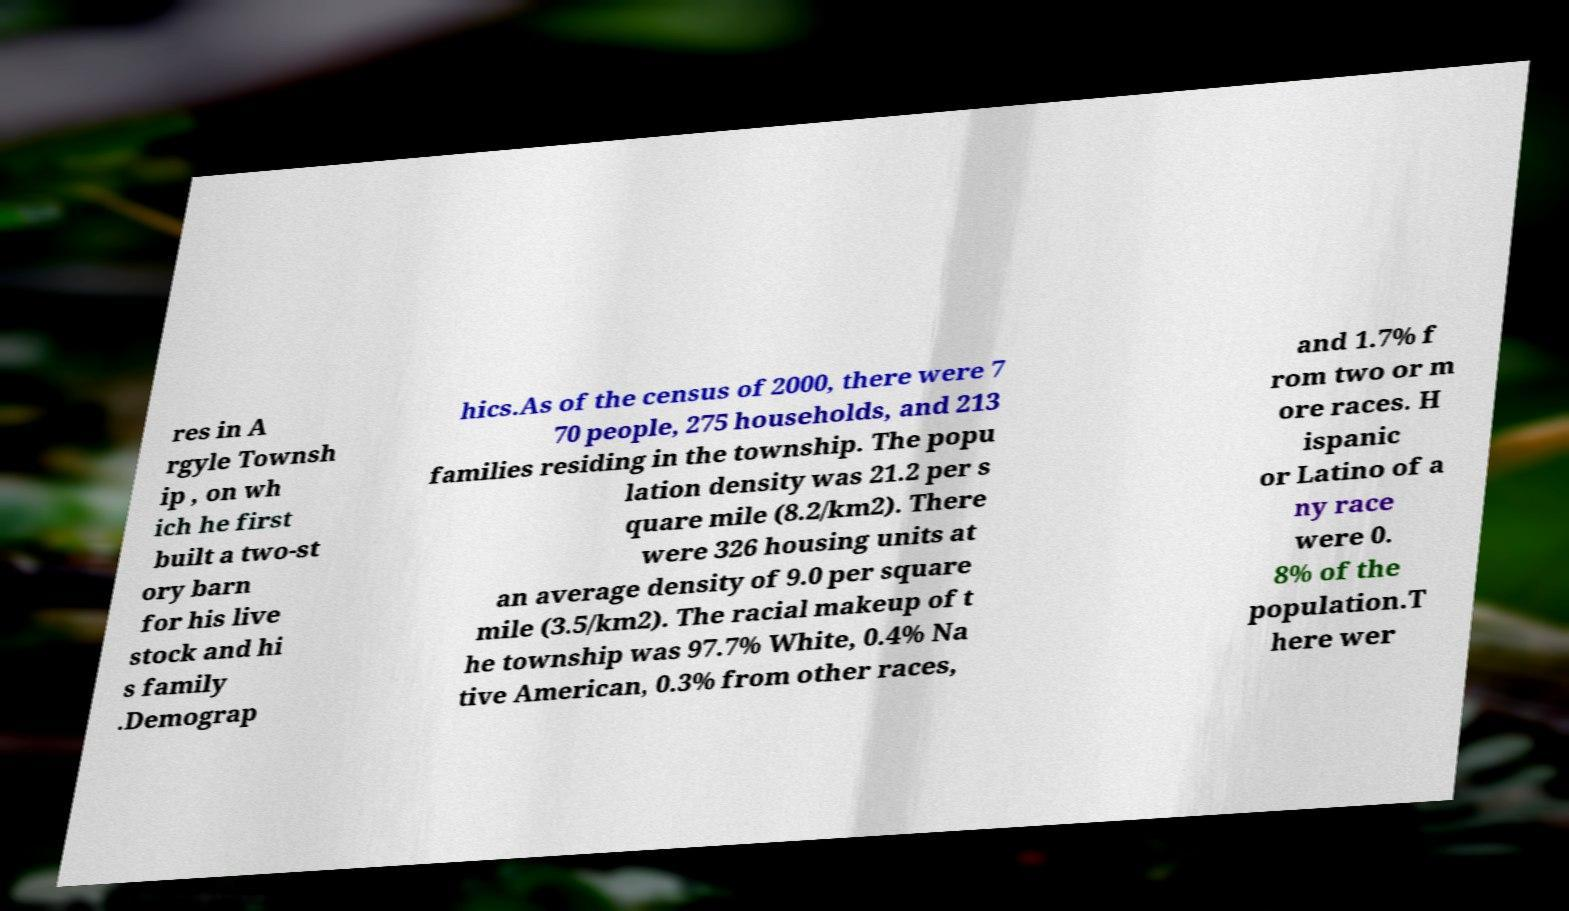Could you extract and type out the text from this image? res in A rgyle Townsh ip , on wh ich he first built a two-st ory barn for his live stock and hi s family .Demograp hics.As of the census of 2000, there were 7 70 people, 275 households, and 213 families residing in the township. The popu lation density was 21.2 per s quare mile (8.2/km2). There were 326 housing units at an average density of 9.0 per square mile (3.5/km2). The racial makeup of t he township was 97.7% White, 0.4% Na tive American, 0.3% from other races, and 1.7% f rom two or m ore races. H ispanic or Latino of a ny race were 0. 8% of the population.T here wer 